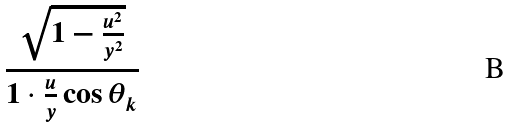<formula> <loc_0><loc_0><loc_500><loc_500>\frac { \sqrt { 1 - \frac { u ^ { 2 } } { y ^ { 2 } } } } { 1 \cdot \frac { u } { y } \cos \theta _ { k } }</formula> 